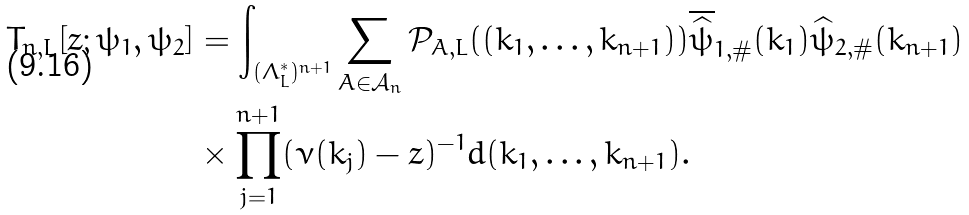<formula> <loc_0><loc_0><loc_500><loc_500>T _ { n , L } [ z ; \psi _ { 1 } , \psi _ { 2 } ] & = \int _ { ( \Lambda _ { L } ^ { * } ) ^ { n + 1 } } \sum _ { A \in \mathcal { A } _ { n } } \mathcal { P } _ { A , L } ( ( k _ { 1 } , \dots , k _ { n + 1 } ) ) \overline { \widehat { \psi } } _ { 1 , \# } ( k _ { 1 } ) \widehat { \psi } _ { 2 , \# } ( k _ { n + 1 } ) \\ & \times \prod _ { j = 1 } ^ { n + 1 } ( \nu ( k _ { j } ) - z ) ^ { - 1 } d ( k _ { 1 } , \dots , k _ { n + 1 } ) .</formula> 